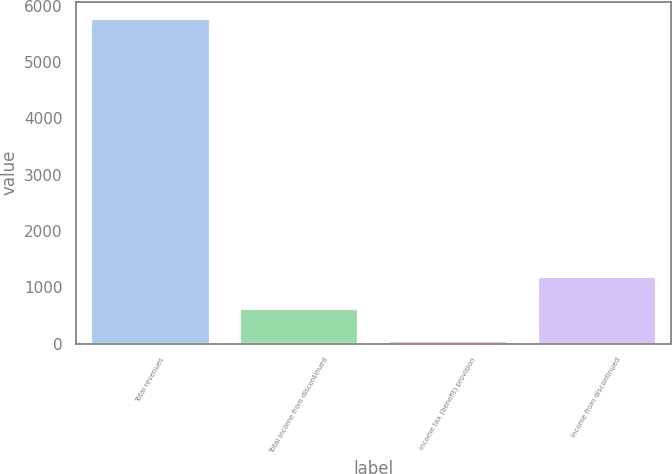Convert chart. <chart><loc_0><loc_0><loc_500><loc_500><bar_chart><fcel>Total revenues<fcel>Total income from discontinued<fcel>Income tax (benefit) provision<fcel>Income from discontinued<nl><fcel>5776<fcel>636.1<fcel>65<fcel>1207.2<nl></chart> 